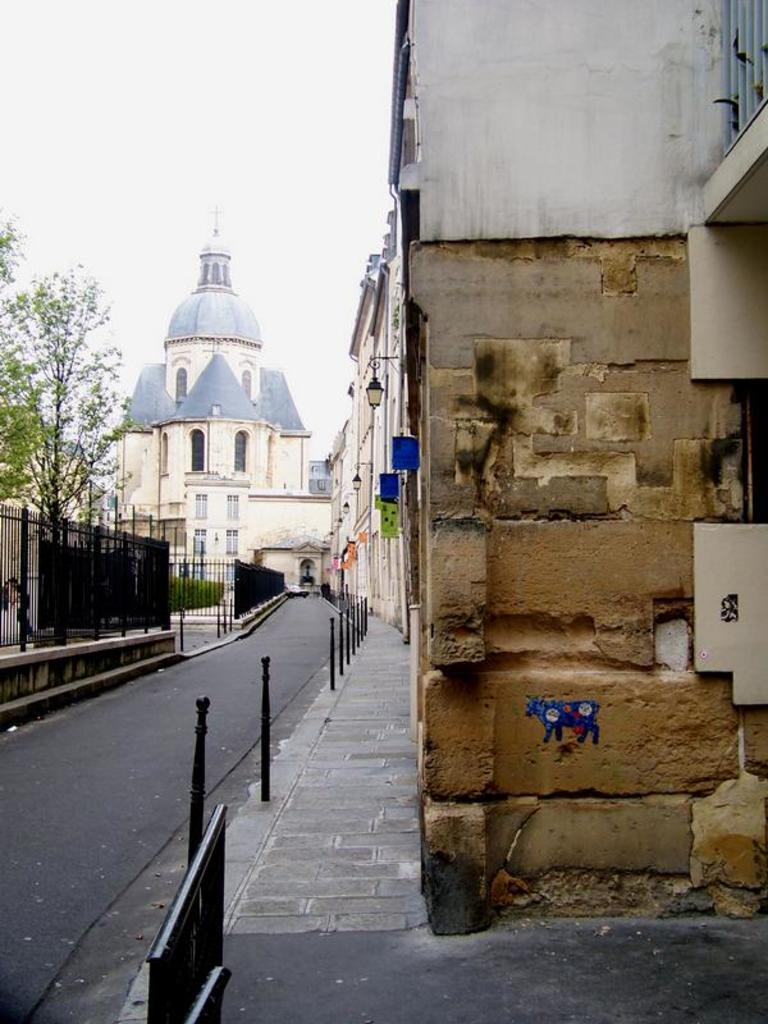How would you summarize this image in a sentence or two? In this picture we can see buildings with windows, fence, trees, road and in the background we can see the sky. 